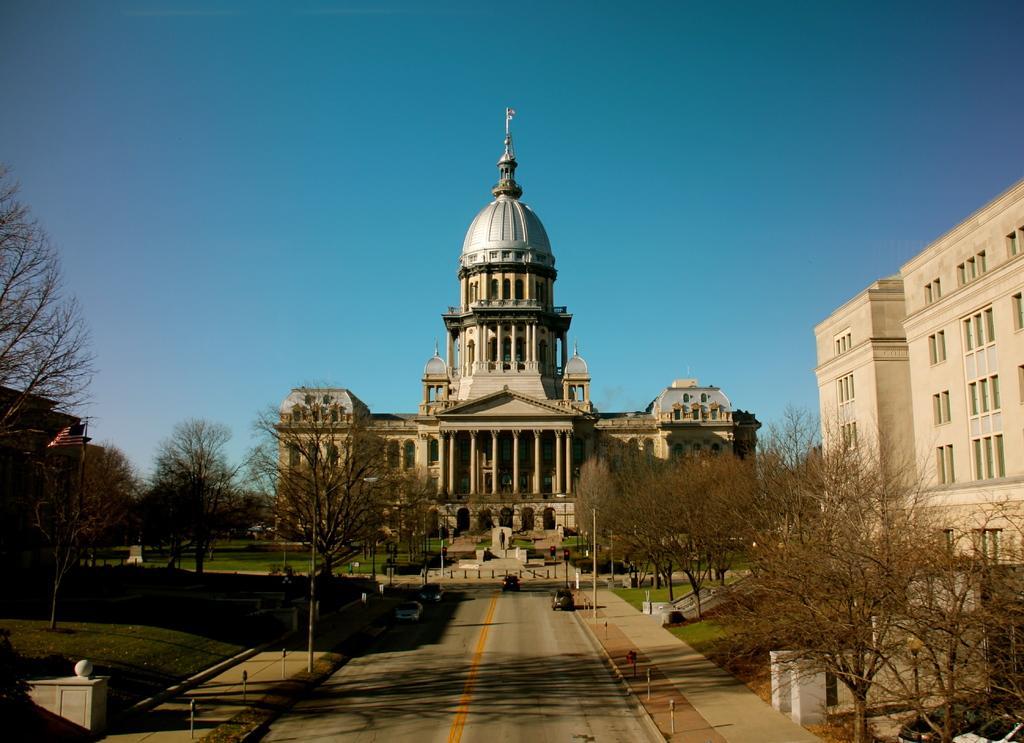Describe this image in one or two sentences. In this image I can see palace, in front of the palace I can see a road , on the road I can see vehicles and I can see trees in the middle ,at the top I can see the sky and on the right side I can see the vehicles 